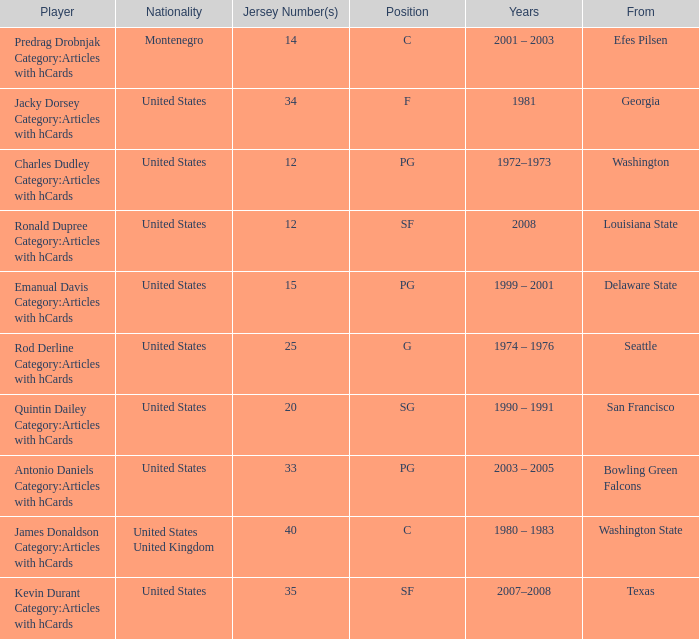From which college did the player wearing the number 34 jersey come? Georgia. 